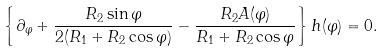Convert formula to latex. <formula><loc_0><loc_0><loc_500><loc_500>\left \{ \partial _ { \varphi } + \frac { R _ { 2 } \sin \varphi } { 2 ( R _ { 1 } + R _ { 2 } \cos \varphi ) } - \frac { R _ { 2 } A ( \varphi ) } { R _ { 1 } + R _ { 2 } \cos \varphi } \right \} h ( \varphi ) = 0 .</formula> 